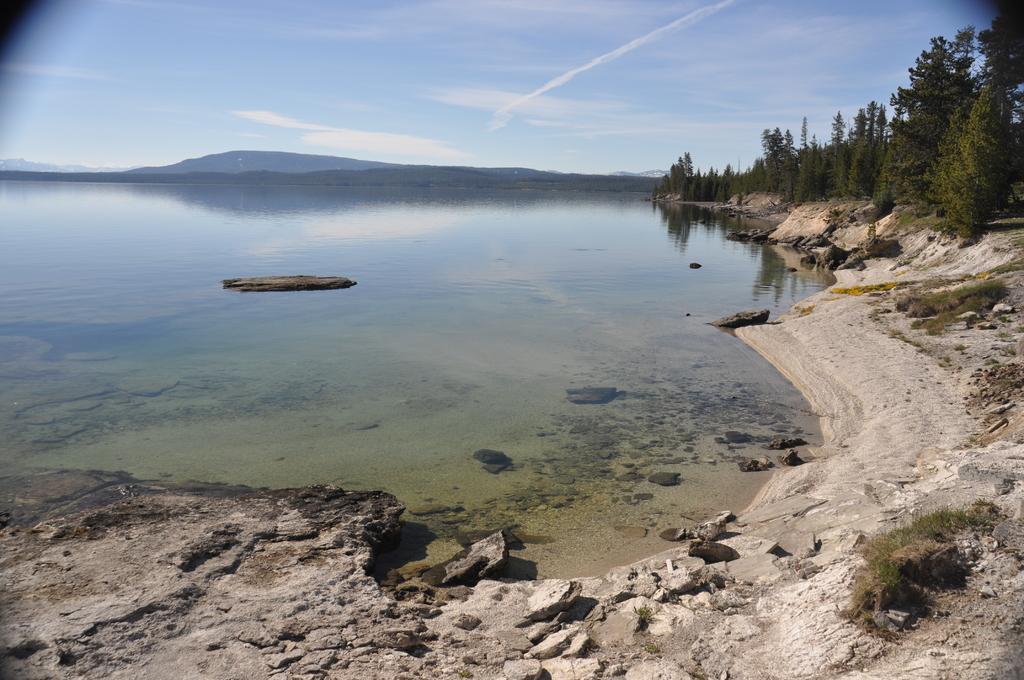In one or two sentences, can you explain what this image depicts? In this picture there is water in the center of the image and there is greenery in the image and there is muddy floor at the bottom side of the image. 